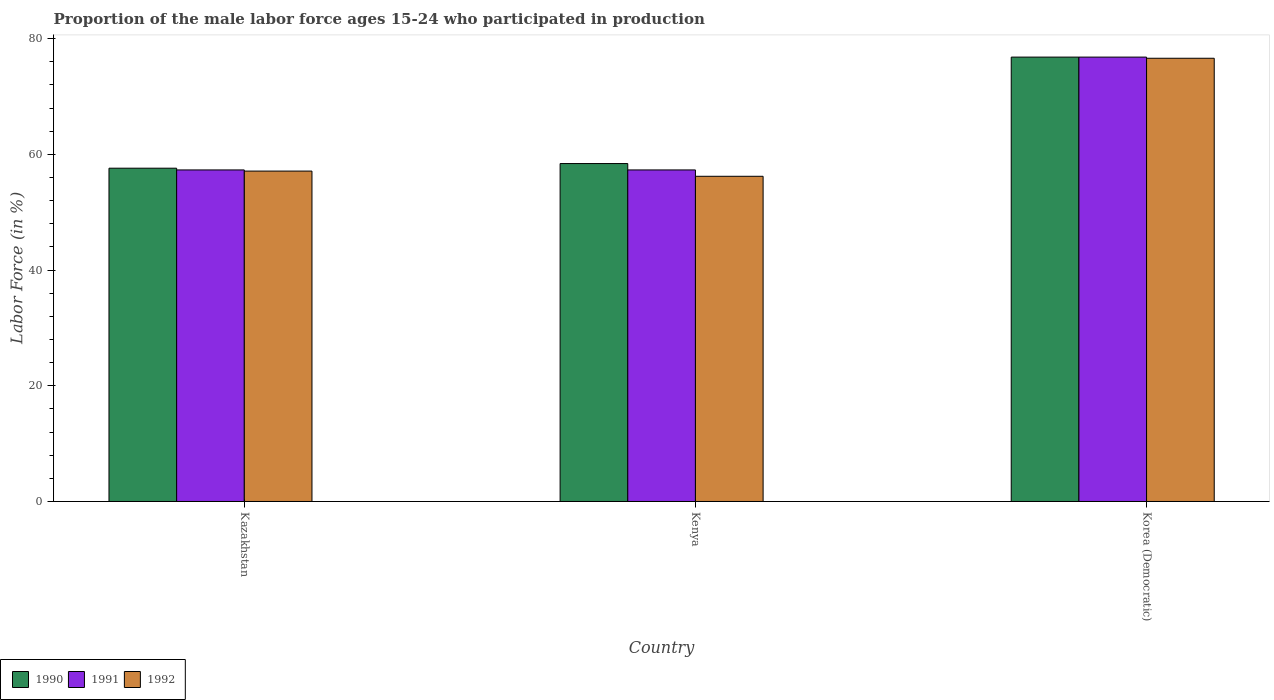How many different coloured bars are there?
Keep it short and to the point. 3. How many groups of bars are there?
Keep it short and to the point. 3. What is the label of the 3rd group of bars from the left?
Your answer should be very brief. Korea (Democratic). What is the proportion of the male labor force who participated in production in 1990 in Kazakhstan?
Your answer should be compact. 57.6. Across all countries, what is the maximum proportion of the male labor force who participated in production in 1992?
Keep it short and to the point. 76.6. Across all countries, what is the minimum proportion of the male labor force who participated in production in 1991?
Provide a succinct answer. 57.3. In which country was the proportion of the male labor force who participated in production in 1992 maximum?
Your answer should be compact. Korea (Democratic). In which country was the proportion of the male labor force who participated in production in 1992 minimum?
Offer a very short reply. Kenya. What is the total proportion of the male labor force who participated in production in 1992 in the graph?
Provide a short and direct response. 189.9. What is the difference between the proportion of the male labor force who participated in production in 1992 in Kazakhstan and that in Korea (Democratic)?
Offer a very short reply. -19.5. What is the difference between the proportion of the male labor force who participated in production in 1991 in Kenya and the proportion of the male labor force who participated in production in 1992 in Kazakhstan?
Ensure brevity in your answer.  0.2. What is the average proportion of the male labor force who participated in production in 1992 per country?
Keep it short and to the point. 63.3. What is the difference between the proportion of the male labor force who participated in production of/in 1992 and proportion of the male labor force who participated in production of/in 1991 in Korea (Democratic)?
Offer a very short reply. -0.2. What is the ratio of the proportion of the male labor force who participated in production in 1992 in Kenya to that in Korea (Democratic)?
Provide a short and direct response. 0.73. What is the difference between the highest and the second highest proportion of the male labor force who participated in production in 1991?
Ensure brevity in your answer.  -19.5. What is the difference between the highest and the lowest proportion of the male labor force who participated in production in 1991?
Offer a terse response. 19.5. In how many countries, is the proportion of the male labor force who participated in production in 1990 greater than the average proportion of the male labor force who participated in production in 1990 taken over all countries?
Your answer should be compact. 1. What does the 3rd bar from the left in Kazakhstan represents?
Provide a short and direct response. 1992. Is it the case that in every country, the sum of the proportion of the male labor force who participated in production in 1992 and proportion of the male labor force who participated in production in 1990 is greater than the proportion of the male labor force who participated in production in 1991?
Offer a terse response. Yes. How many bars are there?
Give a very brief answer. 9. What is the difference between two consecutive major ticks on the Y-axis?
Ensure brevity in your answer.  20. Does the graph contain any zero values?
Your answer should be very brief. No. How are the legend labels stacked?
Ensure brevity in your answer.  Horizontal. What is the title of the graph?
Give a very brief answer. Proportion of the male labor force ages 15-24 who participated in production. Does "1995" appear as one of the legend labels in the graph?
Offer a very short reply. No. What is the label or title of the X-axis?
Your answer should be very brief. Country. What is the label or title of the Y-axis?
Ensure brevity in your answer.  Labor Force (in %). What is the Labor Force (in %) of 1990 in Kazakhstan?
Provide a short and direct response. 57.6. What is the Labor Force (in %) of 1991 in Kazakhstan?
Ensure brevity in your answer.  57.3. What is the Labor Force (in %) of 1992 in Kazakhstan?
Your response must be concise. 57.1. What is the Labor Force (in %) in 1990 in Kenya?
Offer a terse response. 58.4. What is the Labor Force (in %) in 1991 in Kenya?
Give a very brief answer. 57.3. What is the Labor Force (in %) in 1992 in Kenya?
Make the answer very short. 56.2. What is the Labor Force (in %) of 1990 in Korea (Democratic)?
Your answer should be compact. 76.8. What is the Labor Force (in %) of 1991 in Korea (Democratic)?
Make the answer very short. 76.8. What is the Labor Force (in %) in 1992 in Korea (Democratic)?
Provide a short and direct response. 76.6. Across all countries, what is the maximum Labor Force (in %) in 1990?
Provide a succinct answer. 76.8. Across all countries, what is the maximum Labor Force (in %) of 1991?
Your response must be concise. 76.8. Across all countries, what is the maximum Labor Force (in %) in 1992?
Keep it short and to the point. 76.6. Across all countries, what is the minimum Labor Force (in %) in 1990?
Your response must be concise. 57.6. Across all countries, what is the minimum Labor Force (in %) of 1991?
Provide a succinct answer. 57.3. Across all countries, what is the minimum Labor Force (in %) of 1992?
Provide a succinct answer. 56.2. What is the total Labor Force (in %) in 1990 in the graph?
Ensure brevity in your answer.  192.8. What is the total Labor Force (in %) of 1991 in the graph?
Provide a short and direct response. 191.4. What is the total Labor Force (in %) in 1992 in the graph?
Your answer should be compact. 189.9. What is the difference between the Labor Force (in %) of 1991 in Kazakhstan and that in Kenya?
Provide a succinct answer. 0. What is the difference between the Labor Force (in %) in 1990 in Kazakhstan and that in Korea (Democratic)?
Provide a succinct answer. -19.2. What is the difference between the Labor Force (in %) in 1991 in Kazakhstan and that in Korea (Democratic)?
Provide a short and direct response. -19.5. What is the difference between the Labor Force (in %) in 1992 in Kazakhstan and that in Korea (Democratic)?
Provide a short and direct response. -19.5. What is the difference between the Labor Force (in %) of 1990 in Kenya and that in Korea (Democratic)?
Ensure brevity in your answer.  -18.4. What is the difference between the Labor Force (in %) of 1991 in Kenya and that in Korea (Democratic)?
Give a very brief answer. -19.5. What is the difference between the Labor Force (in %) of 1992 in Kenya and that in Korea (Democratic)?
Offer a very short reply. -20.4. What is the difference between the Labor Force (in %) of 1990 in Kazakhstan and the Labor Force (in %) of 1991 in Kenya?
Make the answer very short. 0.3. What is the difference between the Labor Force (in %) of 1990 in Kazakhstan and the Labor Force (in %) of 1991 in Korea (Democratic)?
Your answer should be compact. -19.2. What is the difference between the Labor Force (in %) in 1991 in Kazakhstan and the Labor Force (in %) in 1992 in Korea (Democratic)?
Your answer should be compact. -19.3. What is the difference between the Labor Force (in %) of 1990 in Kenya and the Labor Force (in %) of 1991 in Korea (Democratic)?
Provide a short and direct response. -18.4. What is the difference between the Labor Force (in %) of 1990 in Kenya and the Labor Force (in %) of 1992 in Korea (Democratic)?
Keep it short and to the point. -18.2. What is the difference between the Labor Force (in %) in 1991 in Kenya and the Labor Force (in %) in 1992 in Korea (Democratic)?
Your response must be concise. -19.3. What is the average Labor Force (in %) in 1990 per country?
Make the answer very short. 64.27. What is the average Labor Force (in %) in 1991 per country?
Offer a very short reply. 63.8. What is the average Labor Force (in %) in 1992 per country?
Offer a terse response. 63.3. What is the difference between the Labor Force (in %) in 1990 and Labor Force (in %) in 1991 in Kenya?
Offer a terse response. 1.1. What is the difference between the Labor Force (in %) in 1991 and Labor Force (in %) in 1992 in Kenya?
Your response must be concise. 1.1. What is the difference between the Labor Force (in %) of 1990 and Labor Force (in %) of 1991 in Korea (Democratic)?
Offer a very short reply. 0. What is the ratio of the Labor Force (in %) of 1990 in Kazakhstan to that in Kenya?
Give a very brief answer. 0.99. What is the ratio of the Labor Force (in %) of 1992 in Kazakhstan to that in Kenya?
Your response must be concise. 1.02. What is the ratio of the Labor Force (in %) in 1991 in Kazakhstan to that in Korea (Democratic)?
Provide a short and direct response. 0.75. What is the ratio of the Labor Force (in %) of 1992 in Kazakhstan to that in Korea (Democratic)?
Offer a terse response. 0.75. What is the ratio of the Labor Force (in %) in 1990 in Kenya to that in Korea (Democratic)?
Your answer should be very brief. 0.76. What is the ratio of the Labor Force (in %) in 1991 in Kenya to that in Korea (Democratic)?
Provide a succinct answer. 0.75. What is the ratio of the Labor Force (in %) of 1992 in Kenya to that in Korea (Democratic)?
Provide a succinct answer. 0.73. What is the difference between the highest and the second highest Labor Force (in %) in 1990?
Your answer should be compact. 18.4. What is the difference between the highest and the second highest Labor Force (in %) of 1991?
Your answer should be very brief. 19.5. What is the difference between the highest and the second highest Labor Force (in %) of 1992?
Offer a very short reply. 19.5. What is the difference between the highest and the lowest Labor Force (in %) in 1991?
Make the answer very short. 19.5. What is the difference between the highest and the lowest Labor Force (in %) in 1992?
Offer a very short reply. 20.4. 